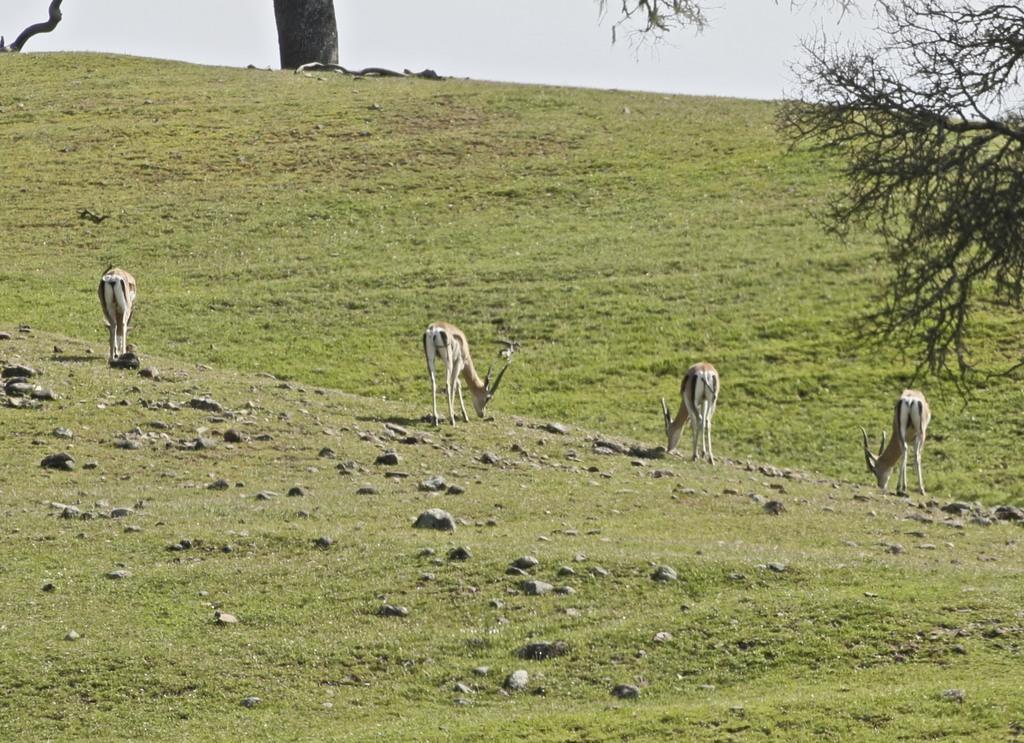Could you give a brief overview of what you see in this image? There are deer in the foreground area of the image on the grassland and there is a trunk, branch and sky at the top side. There is another tree on the right side. 